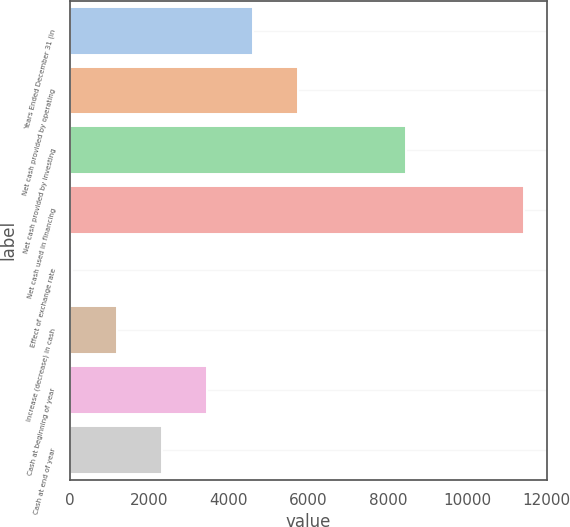<chart> <loc_0><loc_0><loc_500><loc_500><bar_chart><fcel>Years Ended December 31 (in<fcel>Net cash provided by operating<fcel>Net cash provided by investing<fcel>Net cash used in financing<fcel>Effect of exchange rate<fcel>Increase (decrease) in cash<fcel>Cash at beginning of year<fcel>Cash at end of year<nl><fcel>4595<fcel>5734<fcel>8462<fcel>11429<fcel>39<fcel>1178<fcel>3456<fcel>2317<nl></chart> 